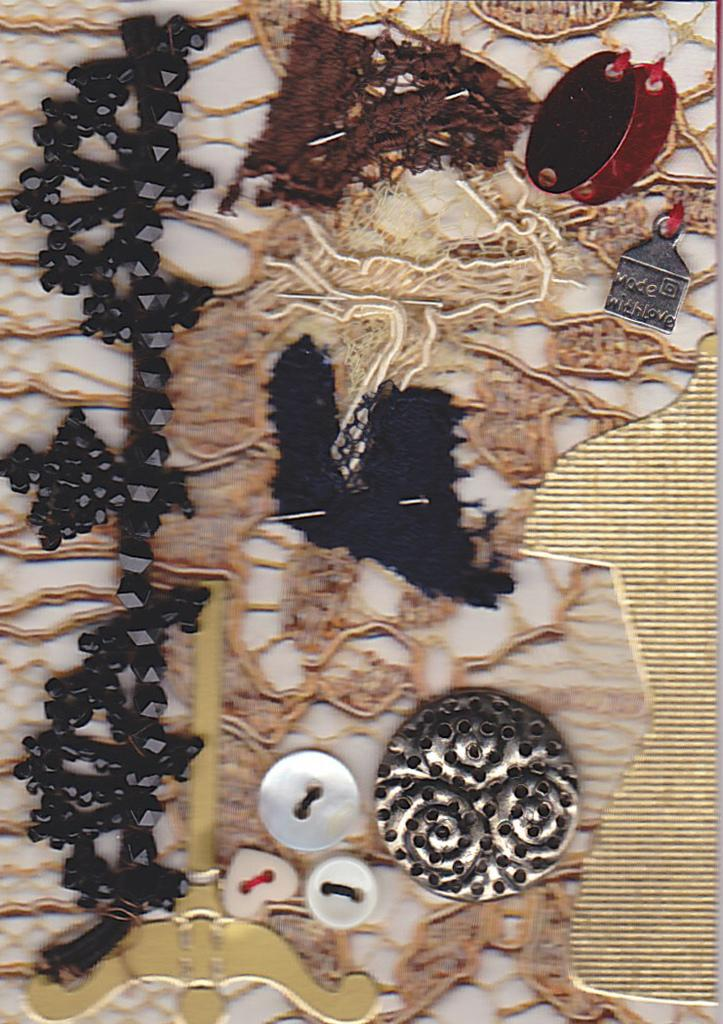What type of objects can be seen in the image? There are buttons and pins in the image. Can you describe the unspecified objects in the image? Unfortunately, the provided facts do not give any information about the unspecified objects in the image. What is the purpose of the buttons and pins in the image? The purpose of the buttons and pins in the image is not specified in the provided facts. What type of attention is the cub receiving from the clouds in the image? There is no cub or clouds present in the image; it only contains buttons and pins. 